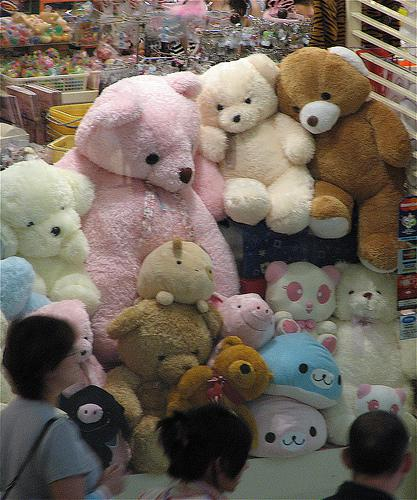Question: what is on the store?
Choices:
A. Roof.
B. Air conditioning units.
C. Stuffed toys.
D. Sign.
Answer with the letter. Answer: C Question: what are the colors of the bears?
Choices:
A. Brown, white, pink.
B. Black.
C. Tan.
D. Red.
Answer with the letter. Answer: A Question: why the stuffed toys are in the store?
Choices:
A. For sale.
B. Decoration.
C. Merchandise.
D. Advertisements.
Answer with the letter. Answer: A Question: how people passing by?
Choices:
A. Three.
B. Walking.
C. Riding bikes.
D. In cars.
Answer with the letter. Answer: A Question: what is the color of the stuffed seal toy?
Choices:
A. Yellow.
B. Blue and pink.
C. Brown.
D. Green.
Answer with the letter. Answer: B 